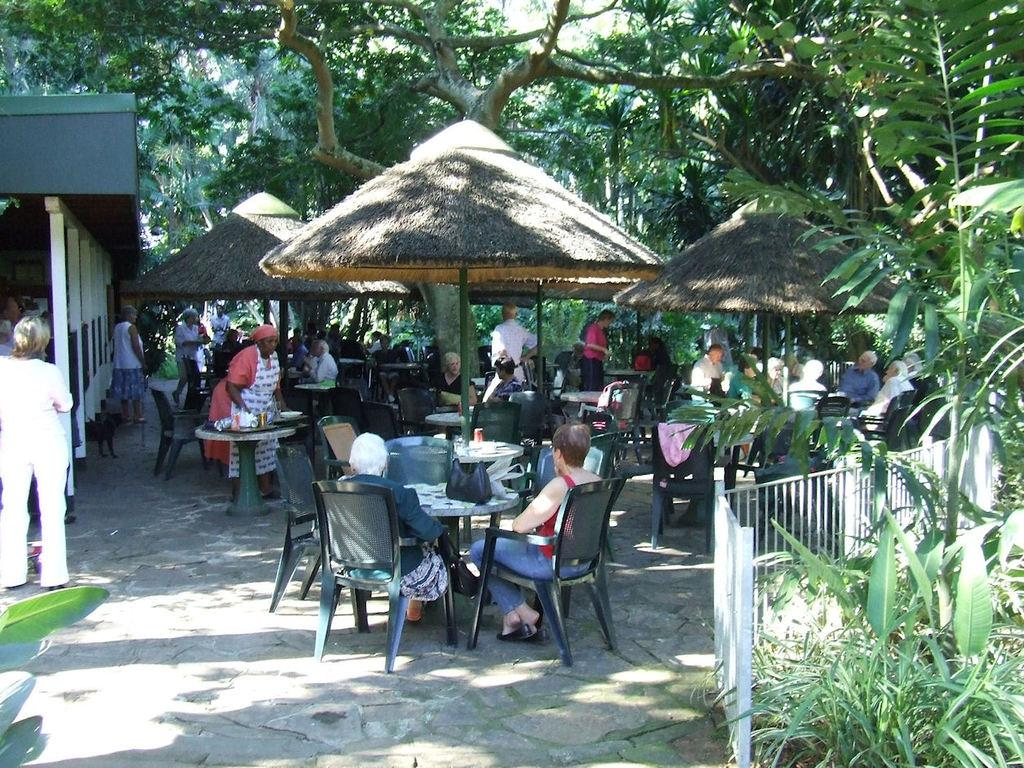What type of furniture is located under the tent in the image? There are chairs and tables under the tent in the image. What can be seen behind the tent? There is a building behind the tent. How many people are present in the image? There are people surrounding the area in the image. What type of stone is being used to ring the bell in the image? There is no bell or stone present in the image. How many bikes are visible in the image? There are no bikes visible in the image. 